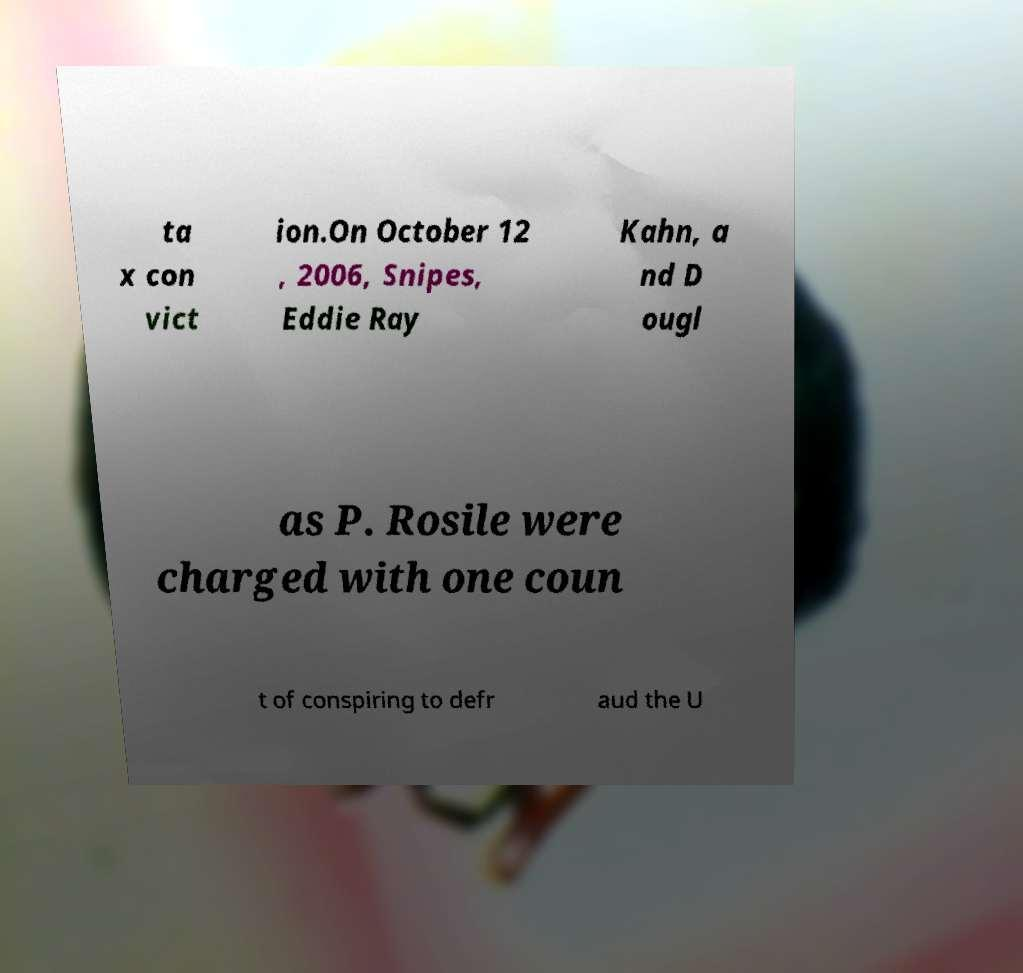Could you assist in decoding the text presented in this image and type it out clearly? ta x con vict ion.On October 12 , 2006, Snipes, Eddie Ray Kahn, a nd D ougl as P. Rosile were charged with one coun t of conspiring to defr aud the U 